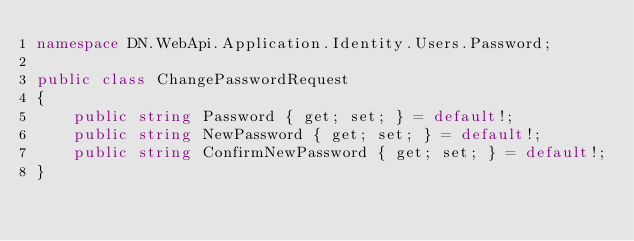Convert code to text. <code><loc_0><loc_0><loc_500><loc_500><_C#_>namespace DN.WebApi.Application.Identity.Users.Password;

public class ChangePasswordRequest
{
    public string Password { get; set; } = default!;
    public string NewPassword { get; set; } = default!;
    public string ConfirmNewPassword { get; set; } = default!;
}</code> 